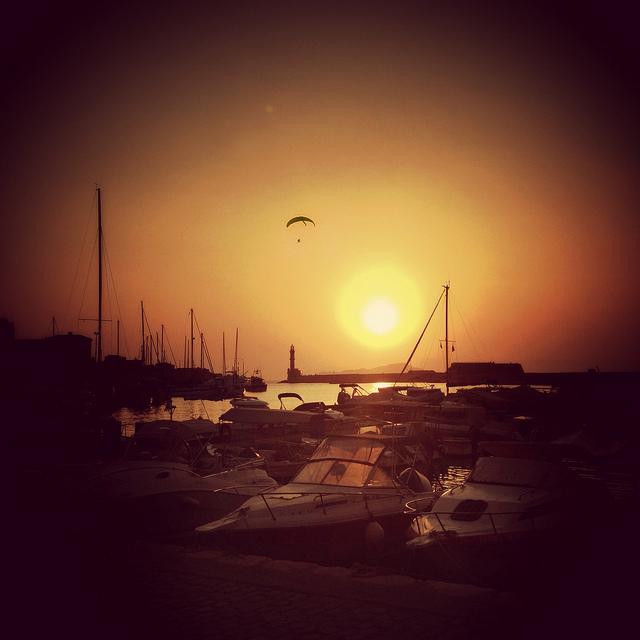What man-made object is present?
Keep it brief. Boat. Is this a port?
Answer briefly. Yes. Could this be in the late evening?
Answer briefly. Yes. What color has this picture been tinted?
Concise answer only. Orange. What is flying in the sky?
Give a very brief answer. Bird. 